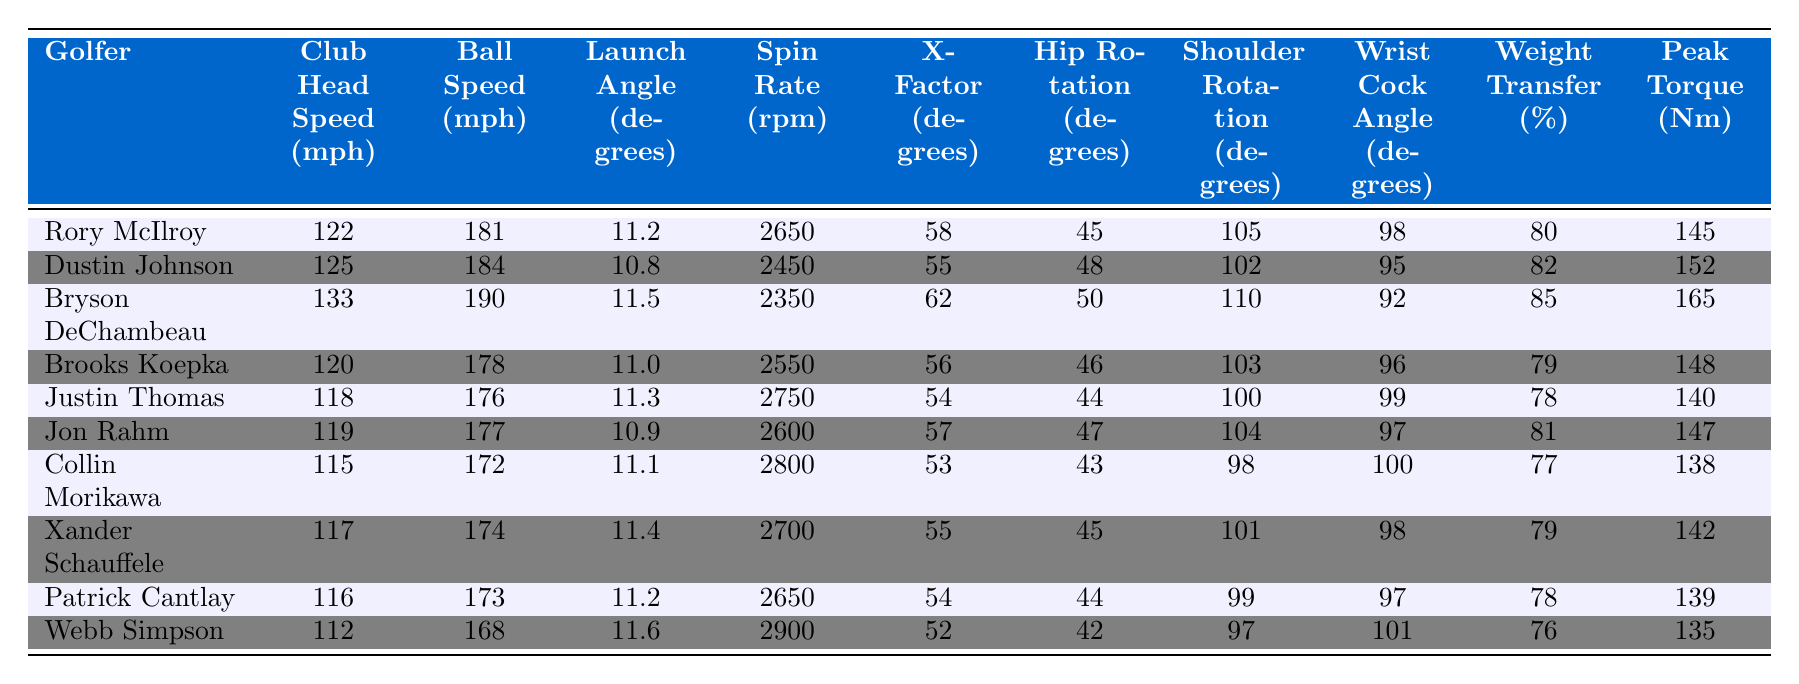What is the club head speed of Bryson DeChambeau? The table lists "Club Head Speed (mph)" for each golfer. Looking for Bryson DeChambeau's row, it reveals that his club head speed is 133 mph.
Answer: 133 mph Who has the highest ball speed? By inspecting the "Ball Speed (mph)" column, Bryson DeChambeau at 190 mph shows as the highest among all golfers listed.
Answer: 190 mph What is the average launch angle of the golfers in the table? To find the average, sum the launch angles: (11.2 + 10.8 + 11.5 + 11.0 + 11.3 + 10.9 + 11.1 + 11.4 + 11.2 + 11.6 = 112.0) and divide by the number of golfers (10). The average is 112.0/10 = 11.2 degrees.
Answer: 11.2 degrees Does Collin Morikawa have a higher peak torque than Rory McIlroy? Checking each golfer's peak torque in the last column, Collin Morikawa's peak torque is 138 Nm, while Rory McIlroy's is 145 Nm. Since 138 is less than 145, the statement is false.
Answer: No What is the difference in spin rate between Justin Thomas and Dustin Johnson? The spin rate for Justin Thomas is 2750 rpm and for Dustin Johnson is 2450 rpm. The difference is calculated by subtracting Dustin's spin rate from Justin's: 2750 - 2450 = 300 rpm.
Answer: 300 rpm Which golfer has the highest X-Factor, and what is its value? Looking at the X-Factor degrees column, Bryson DeChambeau has the highest X-Factor at 62 degrees.
Answer: Bryson DeChambeau, 62 degrees Calculate the total weight transfer percentage for all golfers. The weight transfer percentages are: 80, 82, 85, 79, 78, 81, 77, 79, 78, 76. By summing these values (80 + 82 + 85 + 79 + 78 + 81 + 77 + 79 + 78 + 76 = 799) gives a total of 799%.
Answer: 799% What percentage of golfers have a launch angle greater than 11 degrees? The golfers with a launch angle greater than 11 degrees are Bryson DeChambeau (11.5), Justin Thomas (11.3), Xander Schauffele (11.4), and Webb Simpson (11.6). That's 4 out of 10 golfers, meaning 40% have an angle greater than 11 degrees.
Answer: 40% Which golfer has the lowest wrist cock angle? Inspecting the "Wrist Cock Angle (degrees)" column, Webb Simpson has the lowest wrist cock angle at 101 degrees.
Answer: Webb Simpson, 101 degrees Is the club head speed of any golfer below 115 mph? Reviewing the "Club Head Speed (mph)" column, the lowest value is 112 mph for Webb Simpson, which is below 115 mph. Thus, the answer to the question is yes.
Answer: Yes 